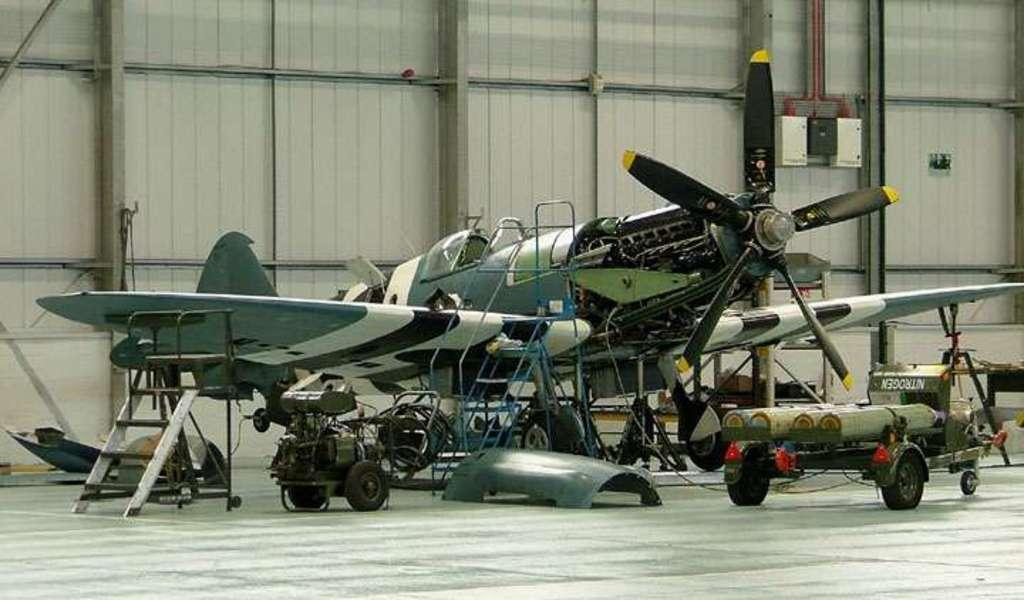What is the main subject of the image? The main subject of the image is a flying jet. What feature of the jet is mentioned in the facts? The jet has tires. What type of surface is visible in the image? There is a floor in the image. What architectural element is present in the image? There is a wall in the image. What type of egg is the carpenter using to perform the action in the image? There is no egg, carpenter, or action present in the image; it features a flying jet with tires and a floor with a wall. 